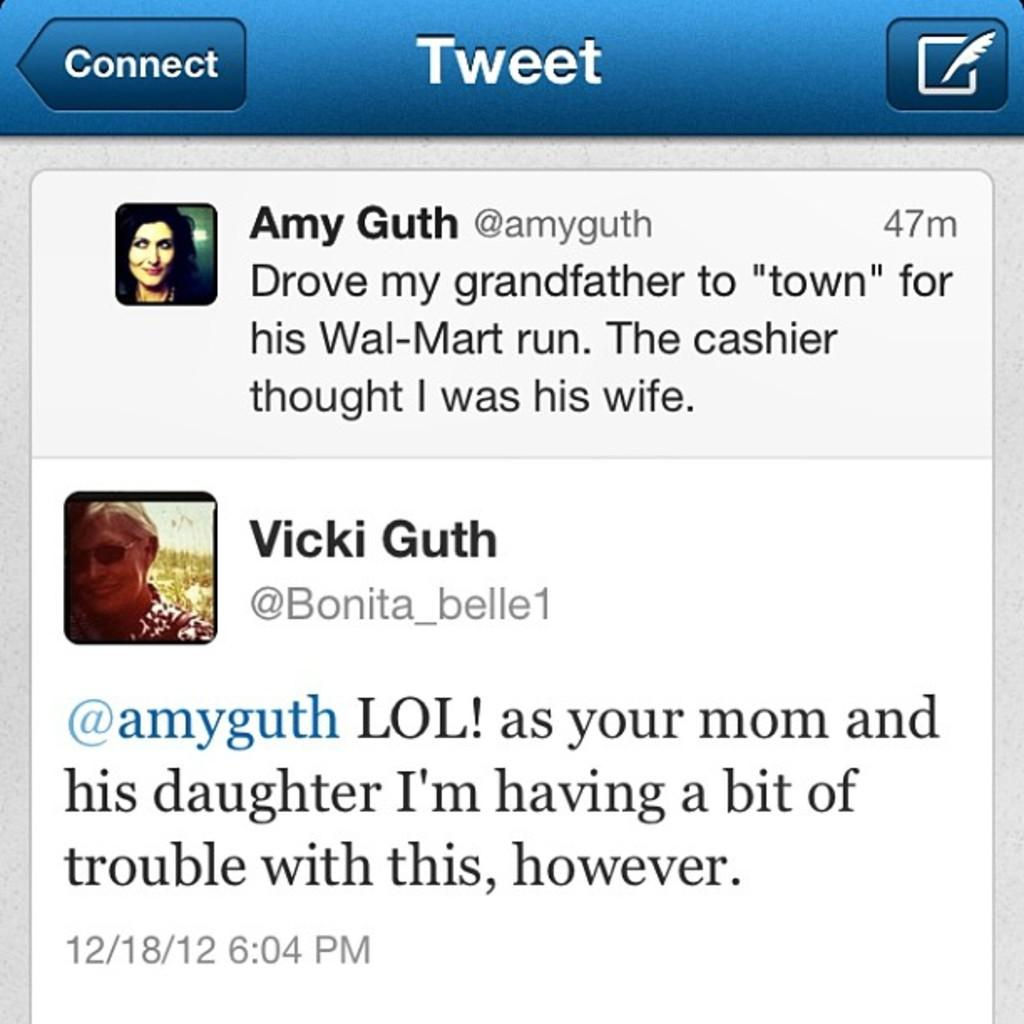What type of visual is the image in question? The image is a poster. What can be found on the poster besides the image? There is text on the poster. What is the main image on the poster? There is an image of a person behind the text. What argument is the person in the image having with the text? There is no argument depicted in the image; it simply shows an image of a person behind the text. 